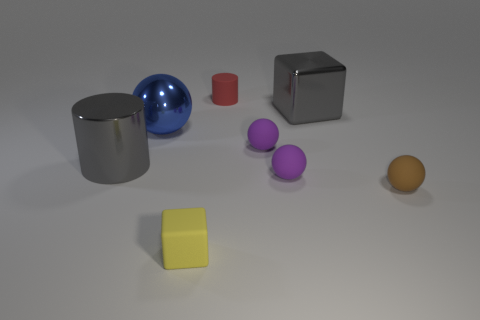There is a cylinder that is the same color as the shiny block; what is its size?
Offer a terse response. Large. The shiny object that is the same color as the big metallic block is what shape?
Give a very brief answer. Cylinder. Does the metal cylinder have the same color as the large metallic block?
Ensure brevity in your answer.  Yes. There is a matte cylinder that is the same size as the yellow matte block; what color is it?
Provide a succinct answer. Red. There is a purple thing that is in front of the big gray metal cylinder; is its size the same as the block that is behind the rubber cube?
Ensure brevity in your answer.  No. There is a metallic object that is right of the block in front of the gray thing to the left of the tiny red object; what size is it?
Provide a short and direct response. Large. What shape is the rubber object behind the block right of the tiny cylinder?
Keep it short and to the point. Cylinder. Does the large shiny object left of the large blue sphere have the same color as the large cube?
Give a very brief answer. Yes. What color is the metallic thing that is behind the large gray cylinder and to the left of the yellow object?
Ensure brevity in your answer.  Blue. Is there a big cube made of the same material as the big cylinder?
Your response must be concise. Yes. 